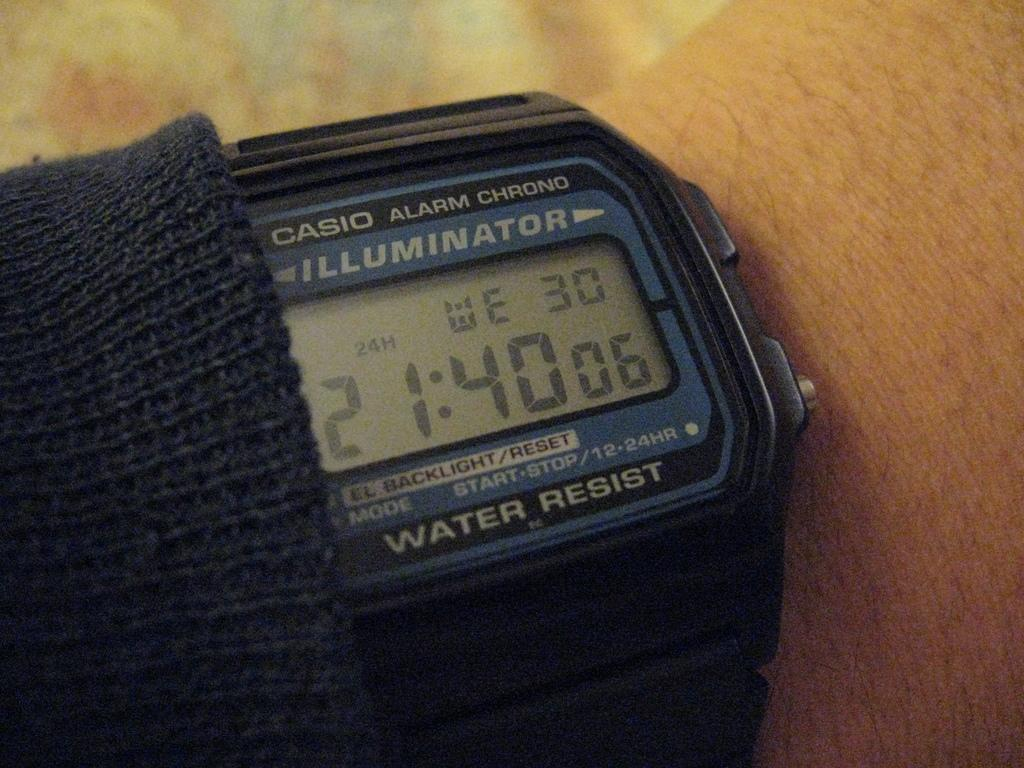Provide a one-sentence caption for the provided image. The Casio watch reads a time of 21:40. 